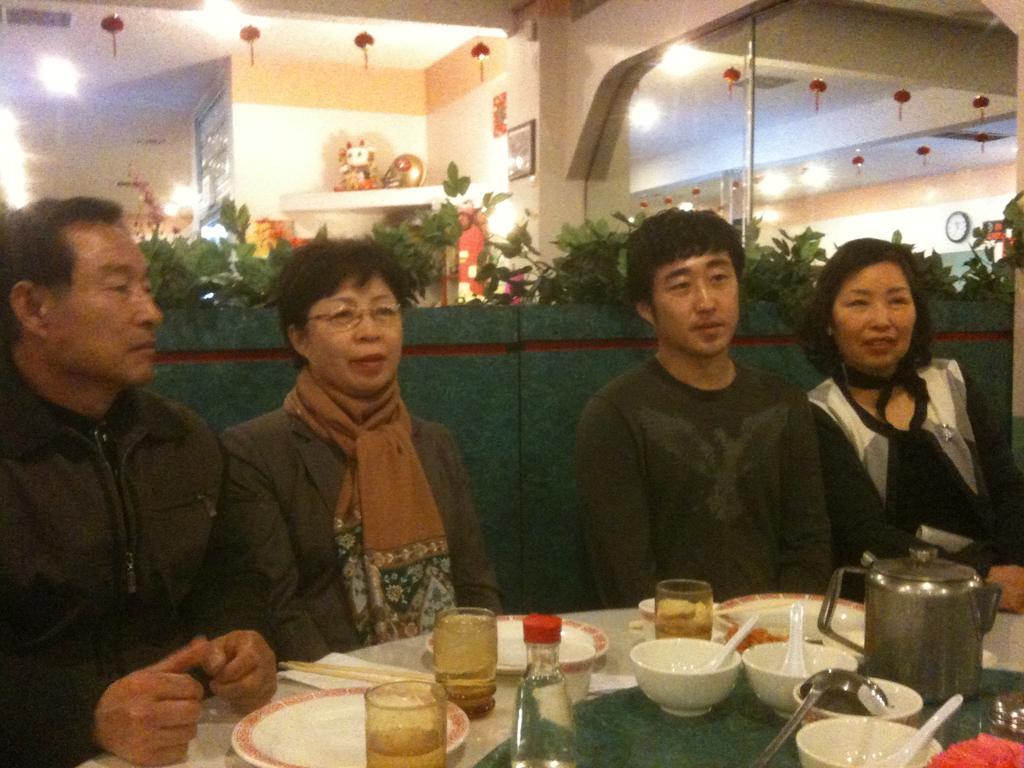Describe this image in one or two sentences. In this image in front there are four persons sitting in front of the table and on top of the table there are plates, glasses, bowls, spoons, can and a bottle. Behind them there is a wall. There are plants, lights, toys. In the background of the image there is wall with the photo frame on it. On the right side of the image there is a glass door. Through the glass door we can see a wall with the wall clock on it. 